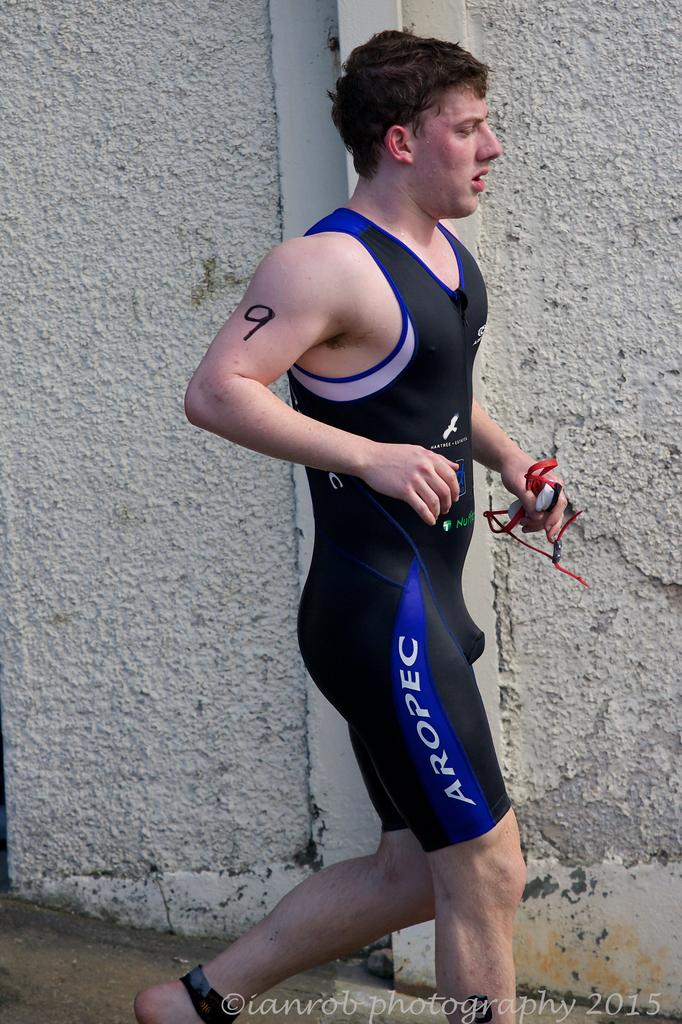<image>
Describe the image concisely. An athlete has the number 9 written on his arm in marker. 